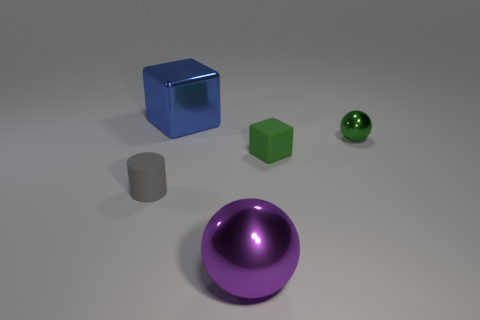Subtract all balls. How many objects are left? 3 Subtract 1 balls. How many balls are left? 1 Subtract 0 cyan cylinders. How many objects are left? 5 Subtract all cyan cylinders. Subtract all green spheres. How many cylinders are left? 1 Subtract all purple cylinders. How many purple balls are left? 1 Subtract all cyan rubber blocks. Subtract all green rubber cubes. How many objects are left? 4 Add 1 gray objects. How many gray objects are left? 2 Add 4 brown balls. How many brown balls exist? 4 Add 3 green metallic things. How many objects exist? 8 Subtract all purple spheres. How many spheres are left? 1 